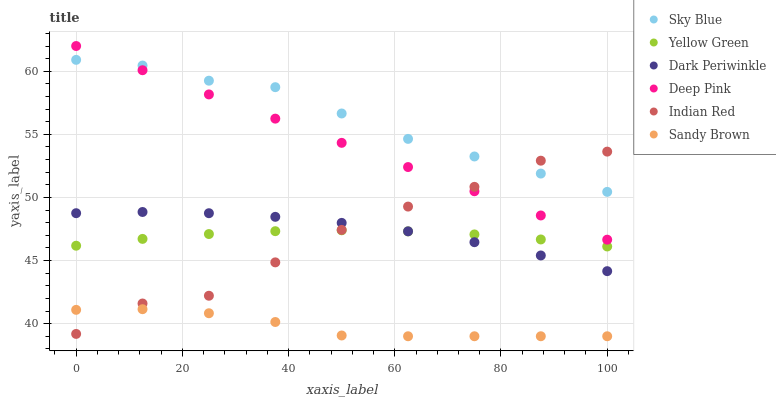Does Sandy Brown have the minimum area under the curve?
Answer yes or no. Yes. Does Sky Blue have the maximum area under the curve?
Answer yes or no. Yes. Does Yellow Green have the minimum area under the curve?
Answer yes or no. No. Does Yellow Green have the maximum area under the curve?
Answer yes or no. No. Is Deep Pink the smoothest?
Answer yes or no. Yes. Is Indian Red the roughest?
Answer yes or no. Yes. Is Yellow Green the smoothest?
Answer yes or no. No. Is Yellow Green the roughest?
Answer yes or no. No. Does Sandy Brown have the lowest value?
Answer yes or no. Yes. Does Yellow Green have the lowest value?
Answer yes or no. No. Does Deep Pink have the highest value?
Answer yes or no. Yes. Does Yellow Green have the highest value?
Answer yes or no. No. Is Sandy Brown less than Yellow Green?
Answer yes or no. Yes. Is Dark Periwinkle greater than Sandy Brown?
Answer yes or no. Yes. Does Sky Blue intersect Deep Pink?
Answer yes or no. Yes. Is Sky Blue less than Deep Pink?
Answer yes or no. No. Is Sky Blue greater than Deep Pink?
Answer yes or no. No. Does Sandy Brown intersect Yellow Green?
Answer yes or no. No. 